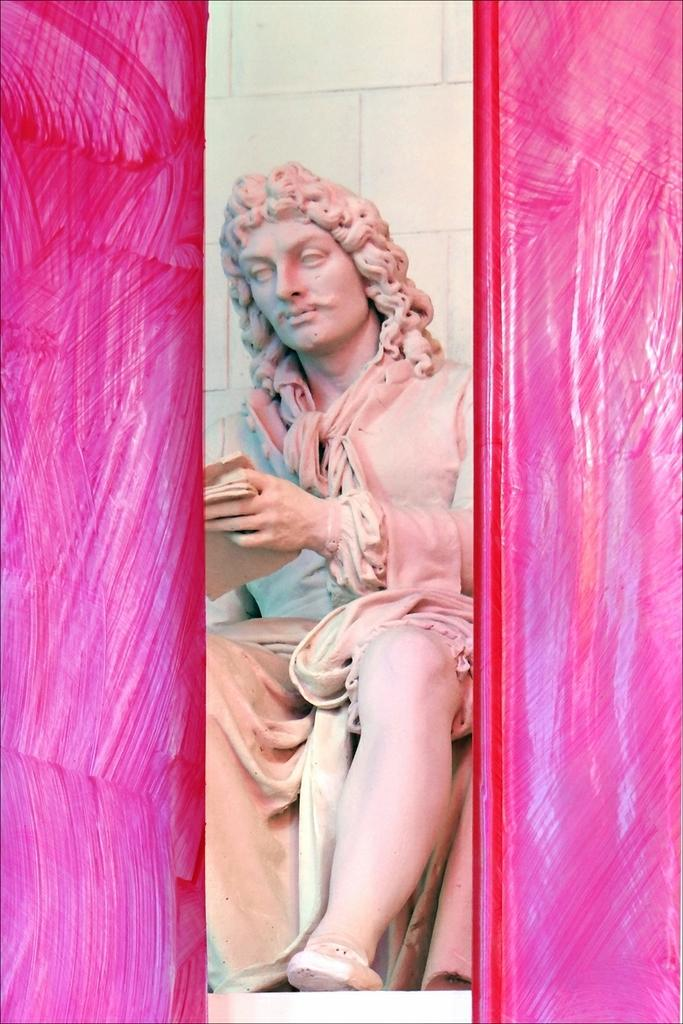What is the main subject of the image? There is a sculpture in the image. Can you describe the color of the sculpture? The sculpture is pink on both the left and right sides of the image. What type of appliance is being used by the passenger in the image? There is no appliance or passenger present in the image; it features a sculpture. 